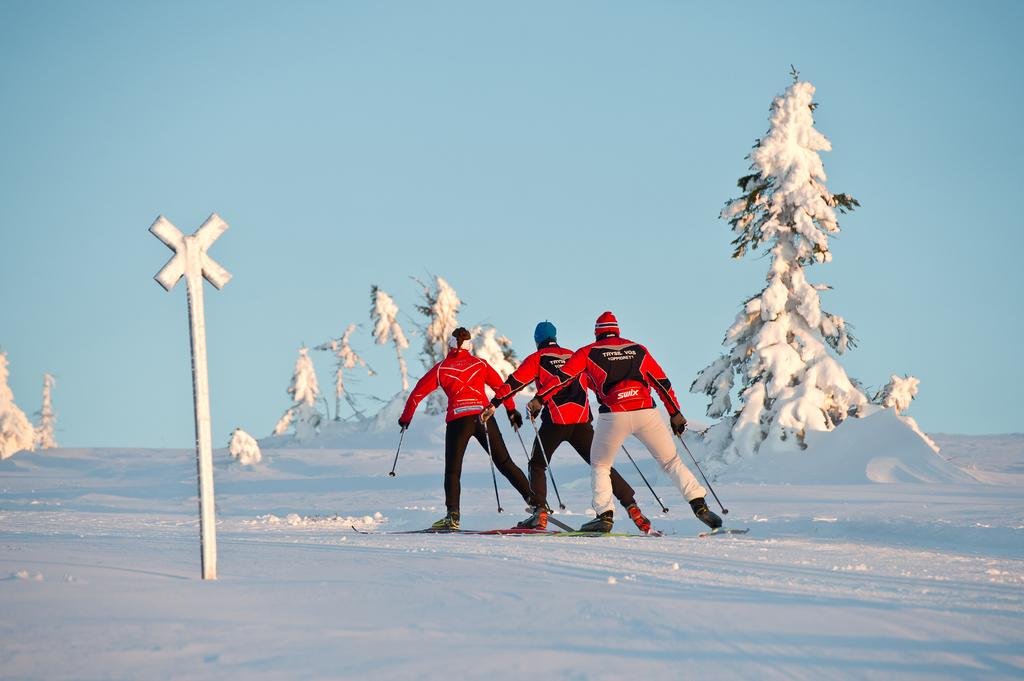What are the three people in the image doing? The three people in the image are skiing. What is the surface they are skiing on? The people are skiing on snow. What can be seen in the background of the image? There are trees and plants in the image. What is the pole used for in the image? The pole's purpose is not specified in the image, but it could be used for skiing or as a marker. What are the people wearing on their heads? The people are wearing caps on their heads. What color jackets are the people wearing? The people are wearing red color jackets. What is the weather like in the image? The sky is cloudy in the image. What type of reaction can be seen from the people at the seashore in the image? There is no seashore present in the image; it features people skiing on snow. What store can be seen in the background of the image? There is no store visible in the image; it features a skiing scene with trees and plants in the background. 